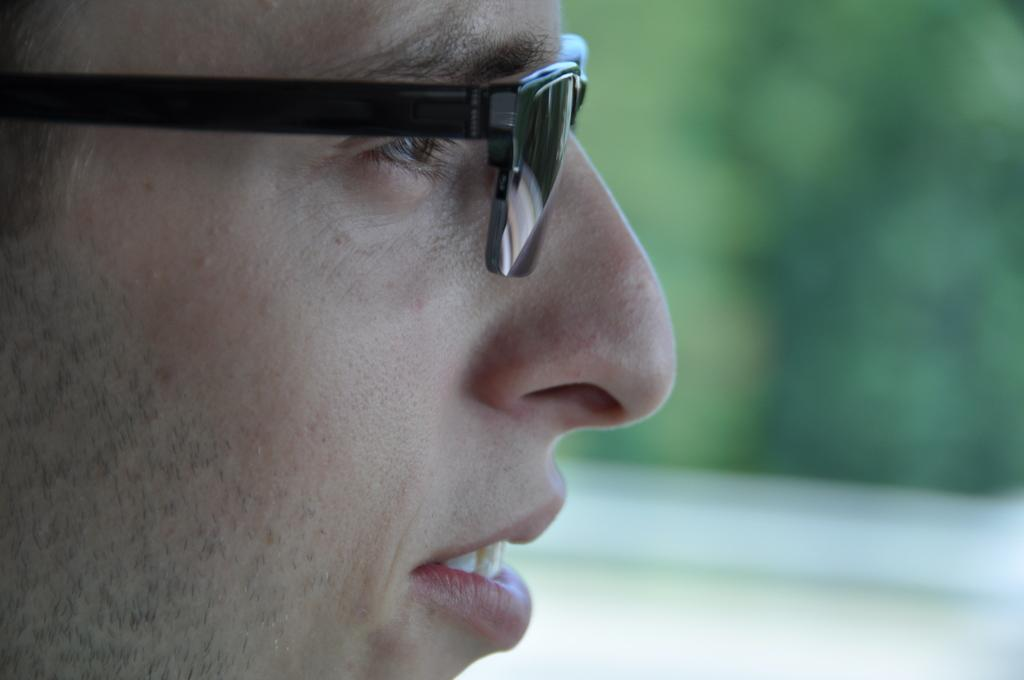Who is the main subject in the image? There is a man in the image. Where is the man located in the image? The man is in the front of the image. What accessory is the man wearing? The man is wearing spectacles. Can you describe the background of the image? The background of the image is blurry. What type of winter clothing is the man wearing in the image? There is no mention of winter clothing in the image; the man is wearing spectacles. How many cows can be seen grazing in the background of the image? There are no cows present in the image; the background is blurry. 